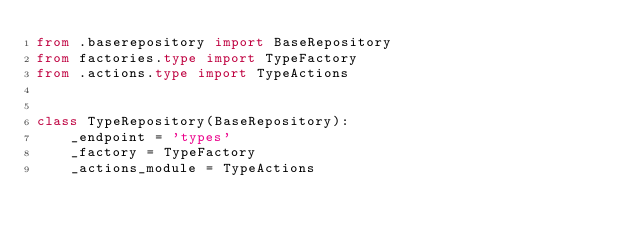<code> <loc_0><loc_0><loc_500><loc_500><_Python_>from .baserepository import BaseRepository
from factories.type import TypeFactory
from .actions.type import TypeActions


class TypeRepository(BaseRepository):
    _endpoint = 'types'
    _factory = TypeFactory
    _actions_module = TypeActions
</code> 